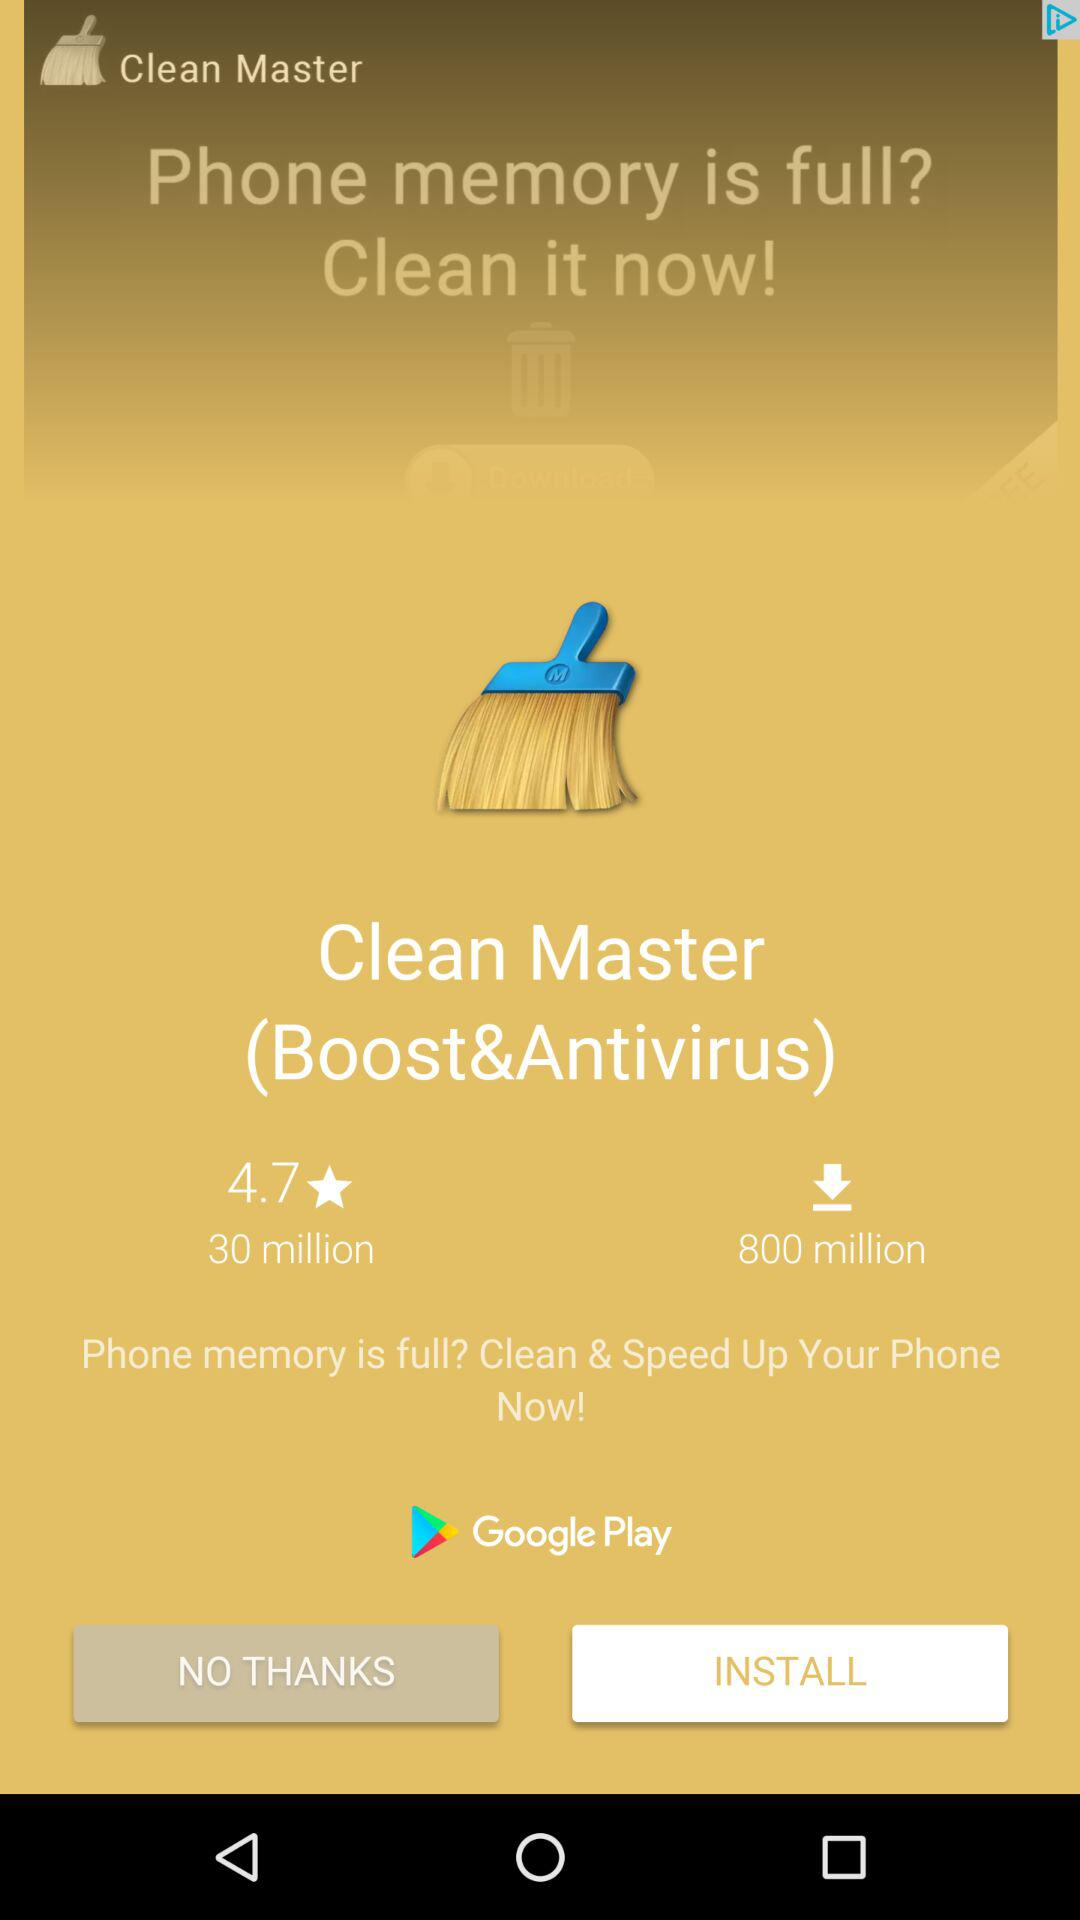How many more downloads does Clean Master have than Clean Master (Boost&Antivirus)?
Answer the question using a single word or phrase. 770 million 